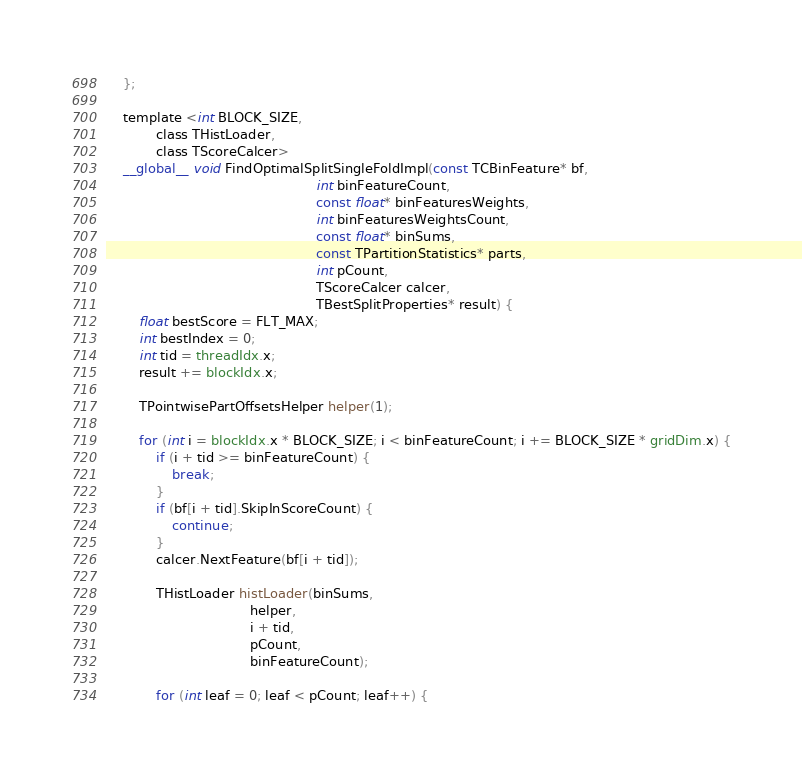Convert code to text. <code><loc_0><loc_0><loc_500><loc_500><_Cuda_>    };

    template <int BLOCK_SIZE,
            class THistLoader,
            class TScoreCalcer>
    __global__ void FindOptimalSplitSingleFoldImpl(const TCBinFeature* bf,
                                                   int binFeatureCount,
                                                   const float* binFeaturesWeights,
                                                   int binFeaturesWeightsCount,
                                                   const float* binSums,
                                                   const TPartitionStatistics* parts,
                                                   int pCount,
                                                   TScoreCalcer calcer,
                                                   TBestSplitProperties* result) {
        float bestScore = FLT_MAX;
        int bestIndex = 0;
        int tid = threadIdx.x;
        result += blockIdx.x;

        TPointwisePartOffsetsHelper helper(1);

        for (int i = blockIdx.x * BLOCK_SIZE; i < binFeatureCount; i += BLOCK_SIZE * gridDim.x) {
            if (i + tid >= binFeatureCount) {
                break;
            }
            if (bf[i + tid].SkipInScoreCount) {
                continue;
            }
            calcer.NextFeature(bf[i + tid]);

            THistLoader histLoader(binSums,
                                   helper,
                                   i + tid,
                                   pCount,
                                   binFeatureCount);

            for (int leaf = 0; leaf < pCount; leaf++) {</code> 